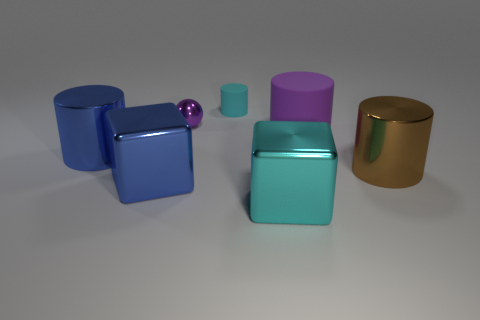Subtract all yellow cylinders. Subtract all gray cubes. How many cylinders are left? 4 Add 3 big blue shiny spheres. How many objects exist? 10 Subtract all spheres. How many objects are left? 6 Subtract 0 gray cylinders. How many objects are left? 7 Subtract all big shiny objects. Subtract all large purple cylinders. How many objects are left? 2 Add 5 metal objects. How many metal objects are left? 10 Add 4 purple metallic things. How many purple metallic things exist? 5 